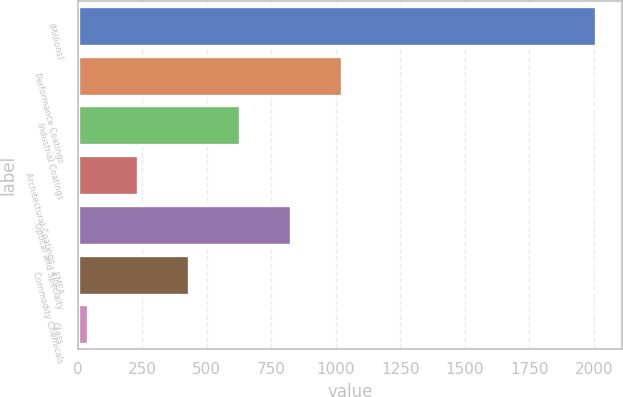Convert chart. <chart><loc_0><loc_0><loc_500><loc_500><bar_chart><fcel>(Millions)<fcel>Performance Coatings<fcel>Industrial Coatings<fcel>Architectural Coatings - EMEA<fcel>Optical and Specialty<fcel>Commodity Chemicals<fcel>Glass<nl><fcel>2009<fcel>1024<fcel>630<fcel>236<fcel>827<fcel>433<fcel>39<nl></chart> 